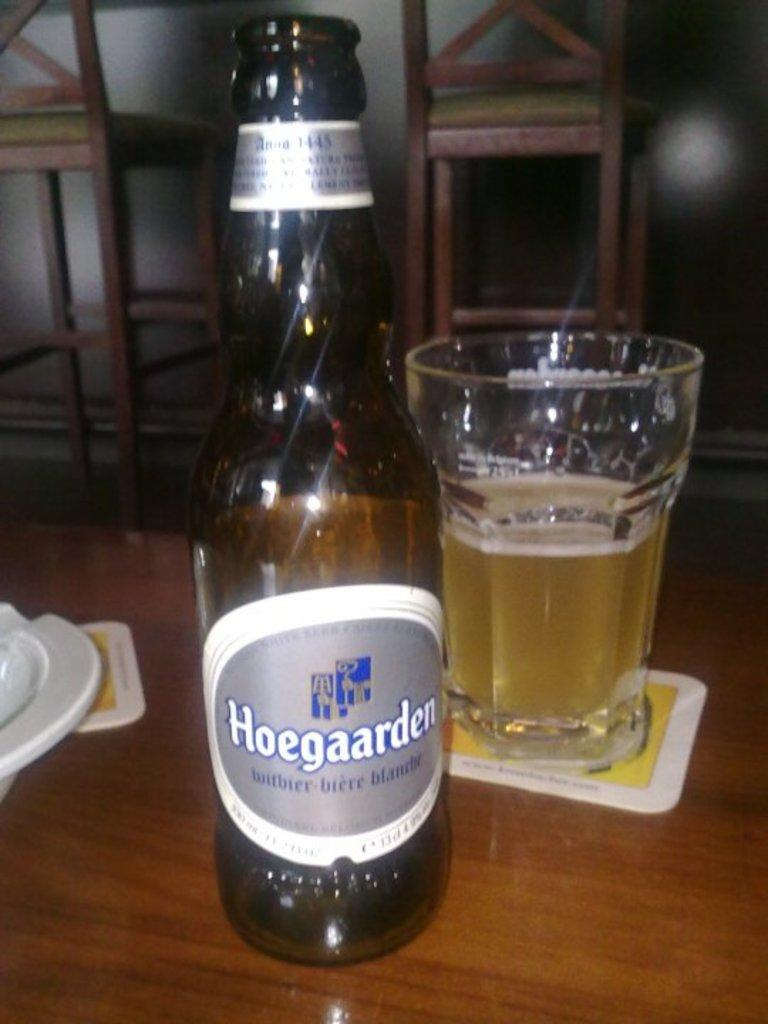<image>
Present a compact description of the photo's key features. a bottle of hoegaarden witbier bier blanche in front of a glass of beer 